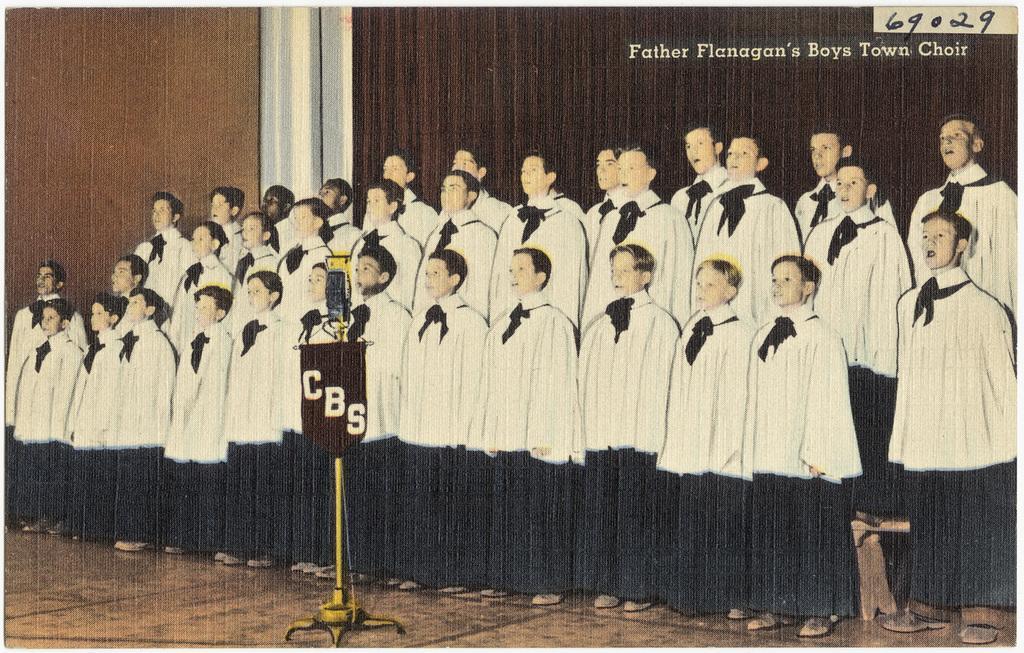In one or two sentences, can you explain what this image depicts? Group of people standing and we can see board on stand. Background we can see wall. Top right of the image we can see text and number. 